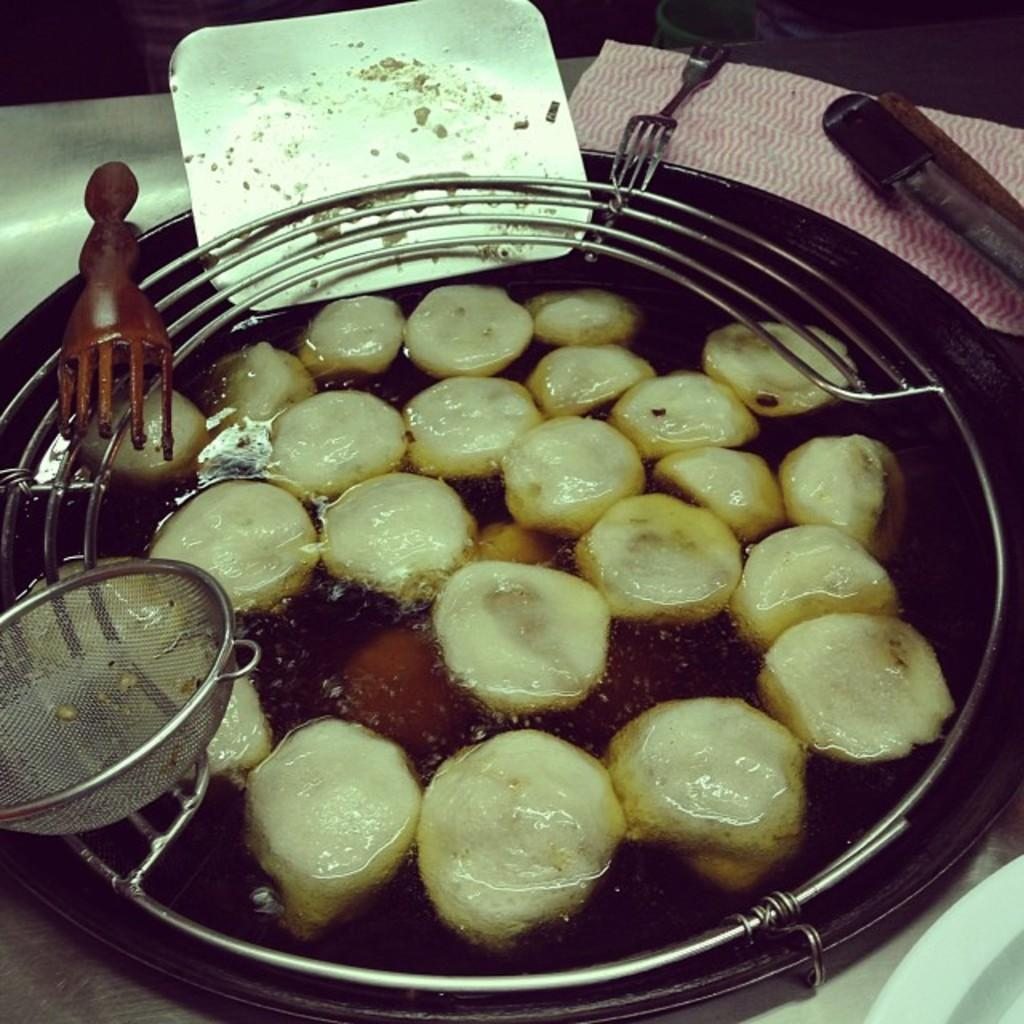What is in the bowl that is visible in the image? There is food in a bowl in the image. Can you describe the utensils present in the image? There is a fork and a spoon in the image. What is the primary surface where the bowl and utensils are located? The objects are on the table in the image. Is there any additional item on the table that might be used for hygiene purposes? There might be tissue on the table in the image. What are the friends reading in the image? There are no friends or reading material present in the image. 